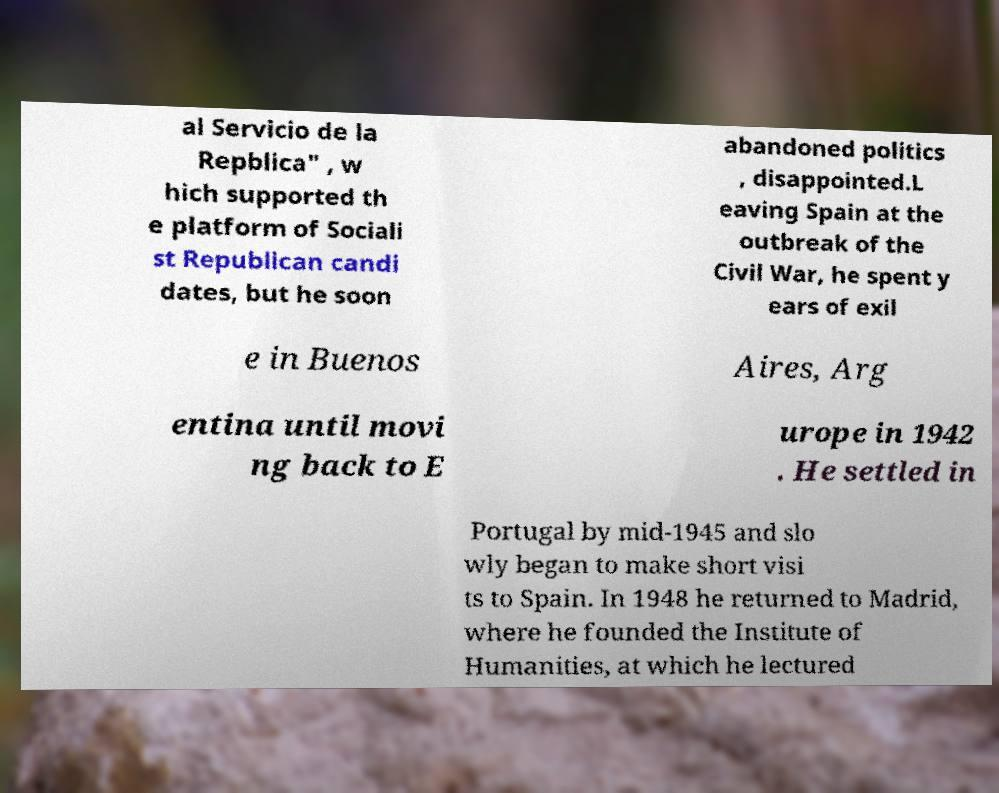Could you extract and type out the text from this image? al Servicio de la Repblica" , w hich supported th e platform of Sociali st Republican candi dates, but he soon abandoned politics , disappointed.L eaving Spain at the outbreak of the Civil War, he spent y ears of exil e in Buenos Aires, Arg entina until movi ng back to E urope in 1942 . He settled in Portugal by mid-1945 and slo wly began to make short visi ts to Spain. In 1948 he returned to Madrid, where he founded the Institute of Humanities, at which he lectured 